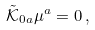Convert formula to latex. <formula><loc_0><loc_0><loc_500><loc_500>\tilde { \mathcal { K } } _ { 0 a } \mu ^ { a } = 0 \, ,</formula> 